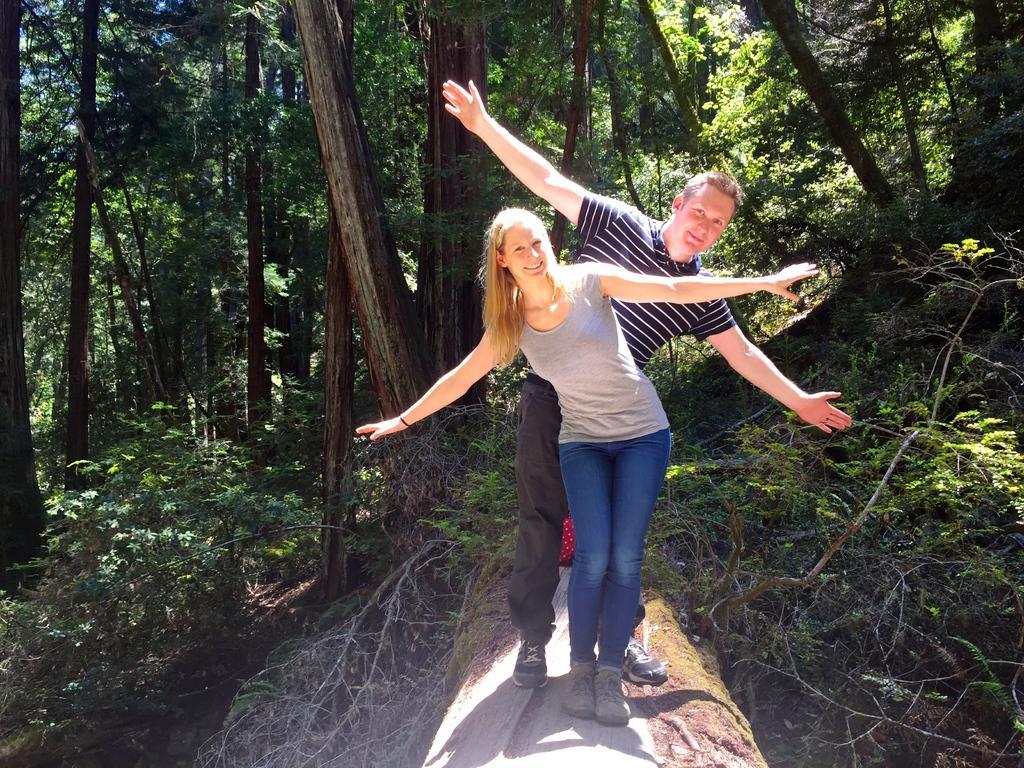Can you describe this image briefly? Here we can see two people. Background there are plants and trees. 